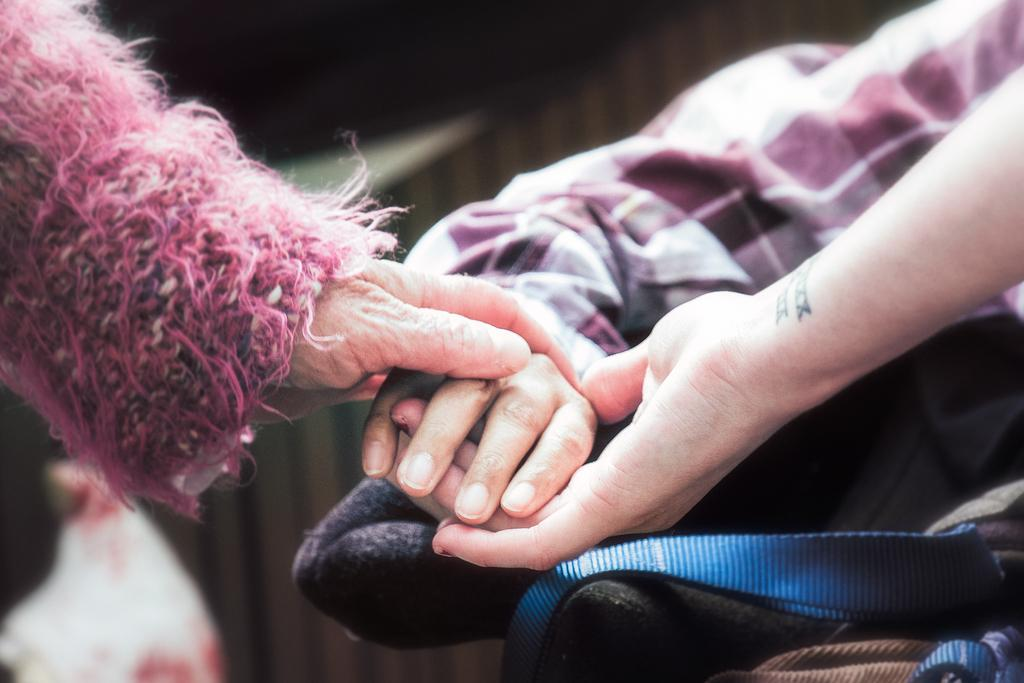What can be seen in the image? There are helping hands in the image. How are the helping hands positioned? The helping hands are holding together. What type of glue is being used to connect the helping hands in the image? There is no glue present in the image; the helping hands are simply holding together. What grade level is the image intended for? The image does not have a specific grade level associated with it. 